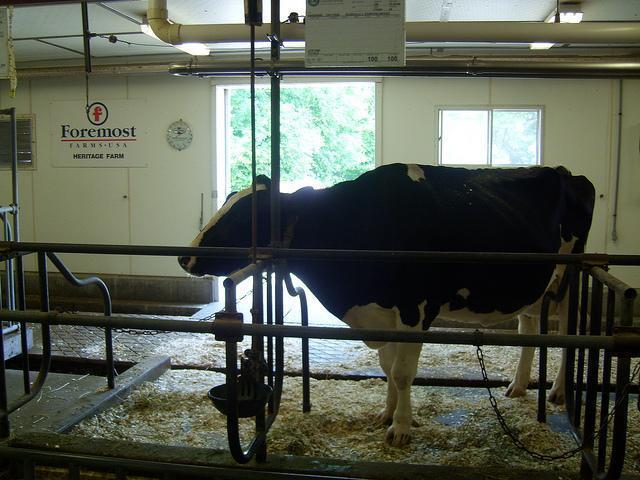How many boats are to the right of the stop sign?
Give a very brief answer. 0. 